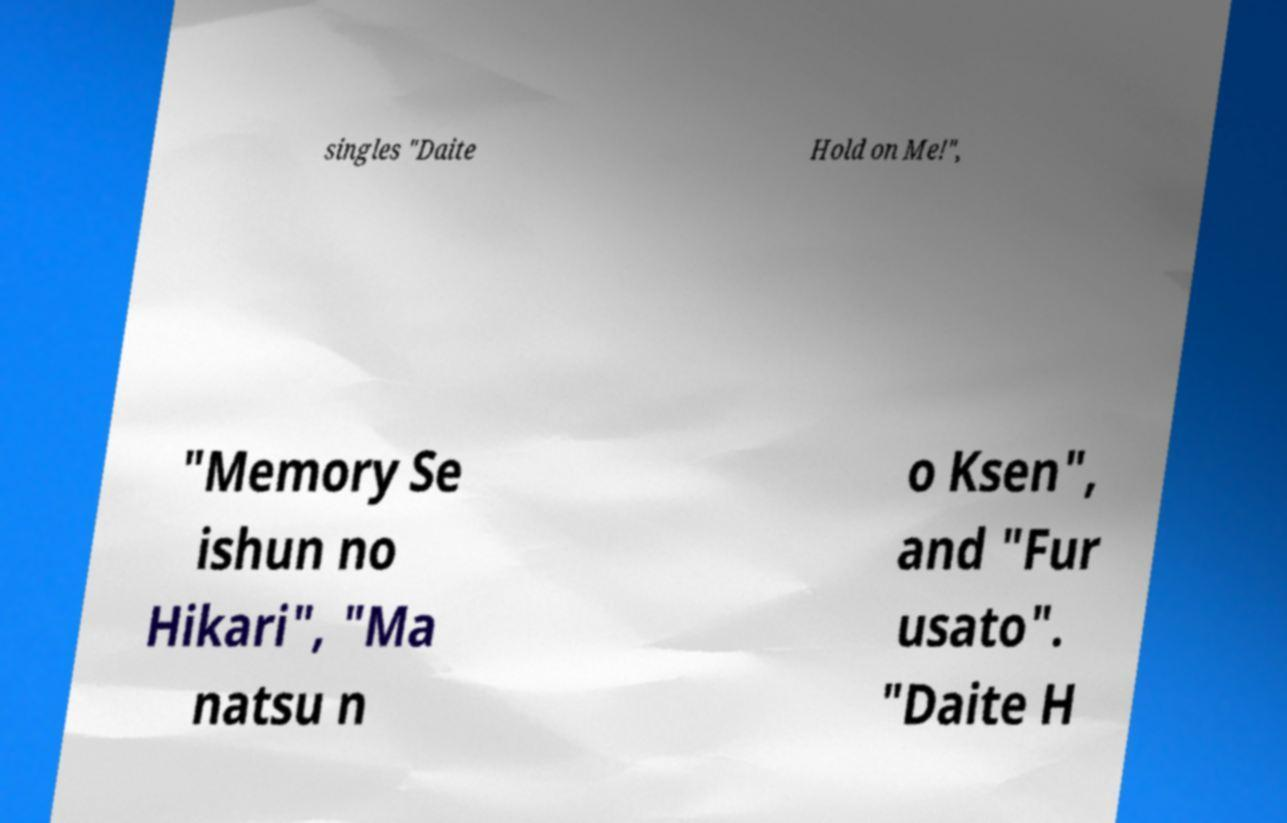Can you read and provide the text displayed in the image?This photo seems to have some interesting text. Can you extract and type it out for me? singles "Daite Hold on Me!", "Memory Se ishun no Hikari", "Ma natsu n o Ksen", and "Fur usato". "Daite H 